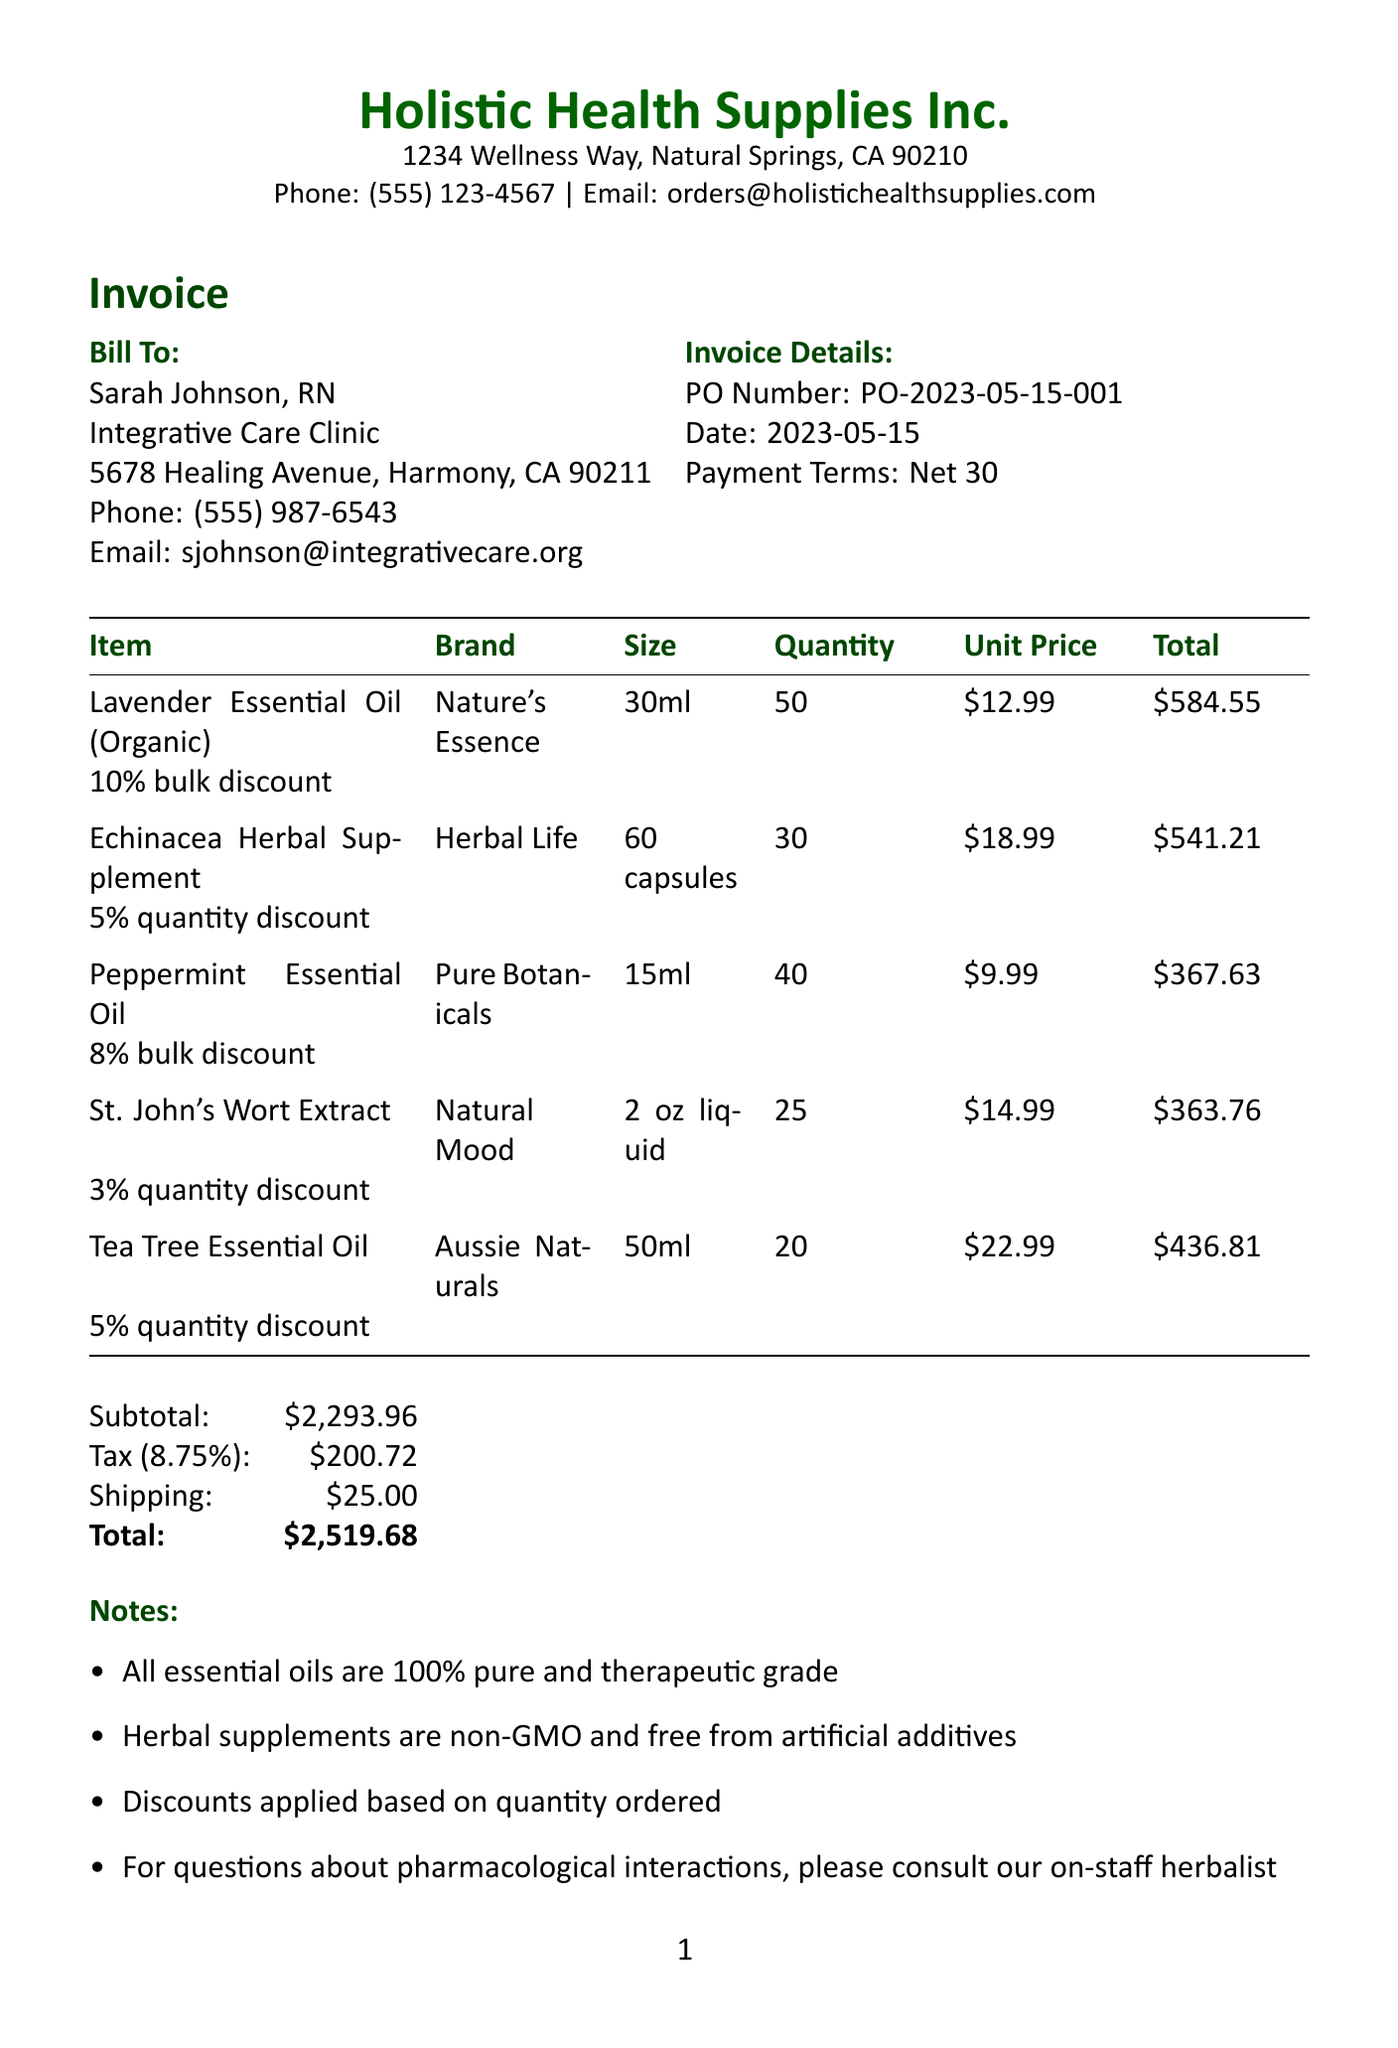what is the name of the company? The company's name is listed at the top of the invoice.
Answer: Holistic Health Supplies Inc who is the customer? The customer information is provided in the document.
Answer: Sarah Johnson, RN what is the purchase order number? The purchase order number is specified in the invoice details section.
Answer: PO-2023-05-15-001 how many Lavender Essential Oils were ordered? The quantity of Lavender Essential Oils is indicated in the item list.
Answer: 50 what is the discount percentage for the Echinacea Herbal Supplement? The discount for the Echinacea Herbal Supplement is noted next to the item.
Answer: 5% quantity discount what is the subtotal amount before tax and shipping? The subtotal is calculated before adding tax and shipping.
Answer: $2,293.96 what is the total cost including tax and shipping? The total cost is at the bottom of the invoice after tax and shipping are added.
Answer: $2,519.68 what are the payment terms listed on the invoice? The payment terms are provided in the invoice details section.
Answer: Net 30 what is one of the notes mentioned in the invoice? The notes section contains additional important information.
Answer: All essential oils are 100% pure and therapeutic grade 